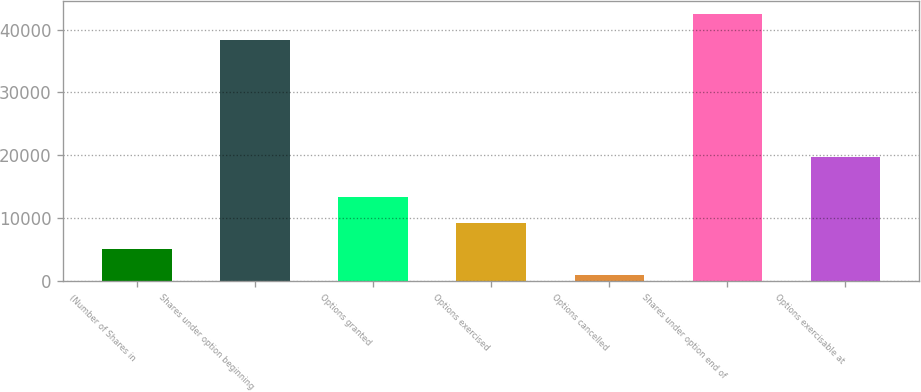Convert chart to OTSL. <chart><loc_0><loc_0><loc_500><loc_500><bar_chart><fcel>(Number of Shares in<fcel>Shares under option beginning<fcel>Options granted<fcel>Options exercised<fcel>Options cancelled<fcel>Shares under option end of<fcel>Options exercisable at<nl><fcel>5167.4<fcel>38314<fcel>13428.2<fcel>9297.8<fcel>1037<fcel>42444.4<fcel>19758<nl></chart> 